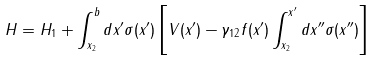Convert formula to latex. <formula><loc_0><loc_0><loc_500><loc_500>H = H _ { 1 } + \int _ { x _ { 2 } } ^ { b } d x ^ { \prime } \sigma ( x ^ { \prime } ) \left [ V ( x ^ { \prime } ) - \gamma _ { 1 2 } f ( x ^ { \prime } ) \int _ { x _ { 2 } } ^ { x ^ { \prime } } d x ^ { \prime \prime } \sigma ( x ^ { \prime \prime } ) \right ]</formula> 